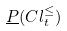Convert formula to latex. <formula><loc_0><loc_0><loc_500><loc_500>\underline { P } ( C l _ { t } ^ { \leq } )</formula> 